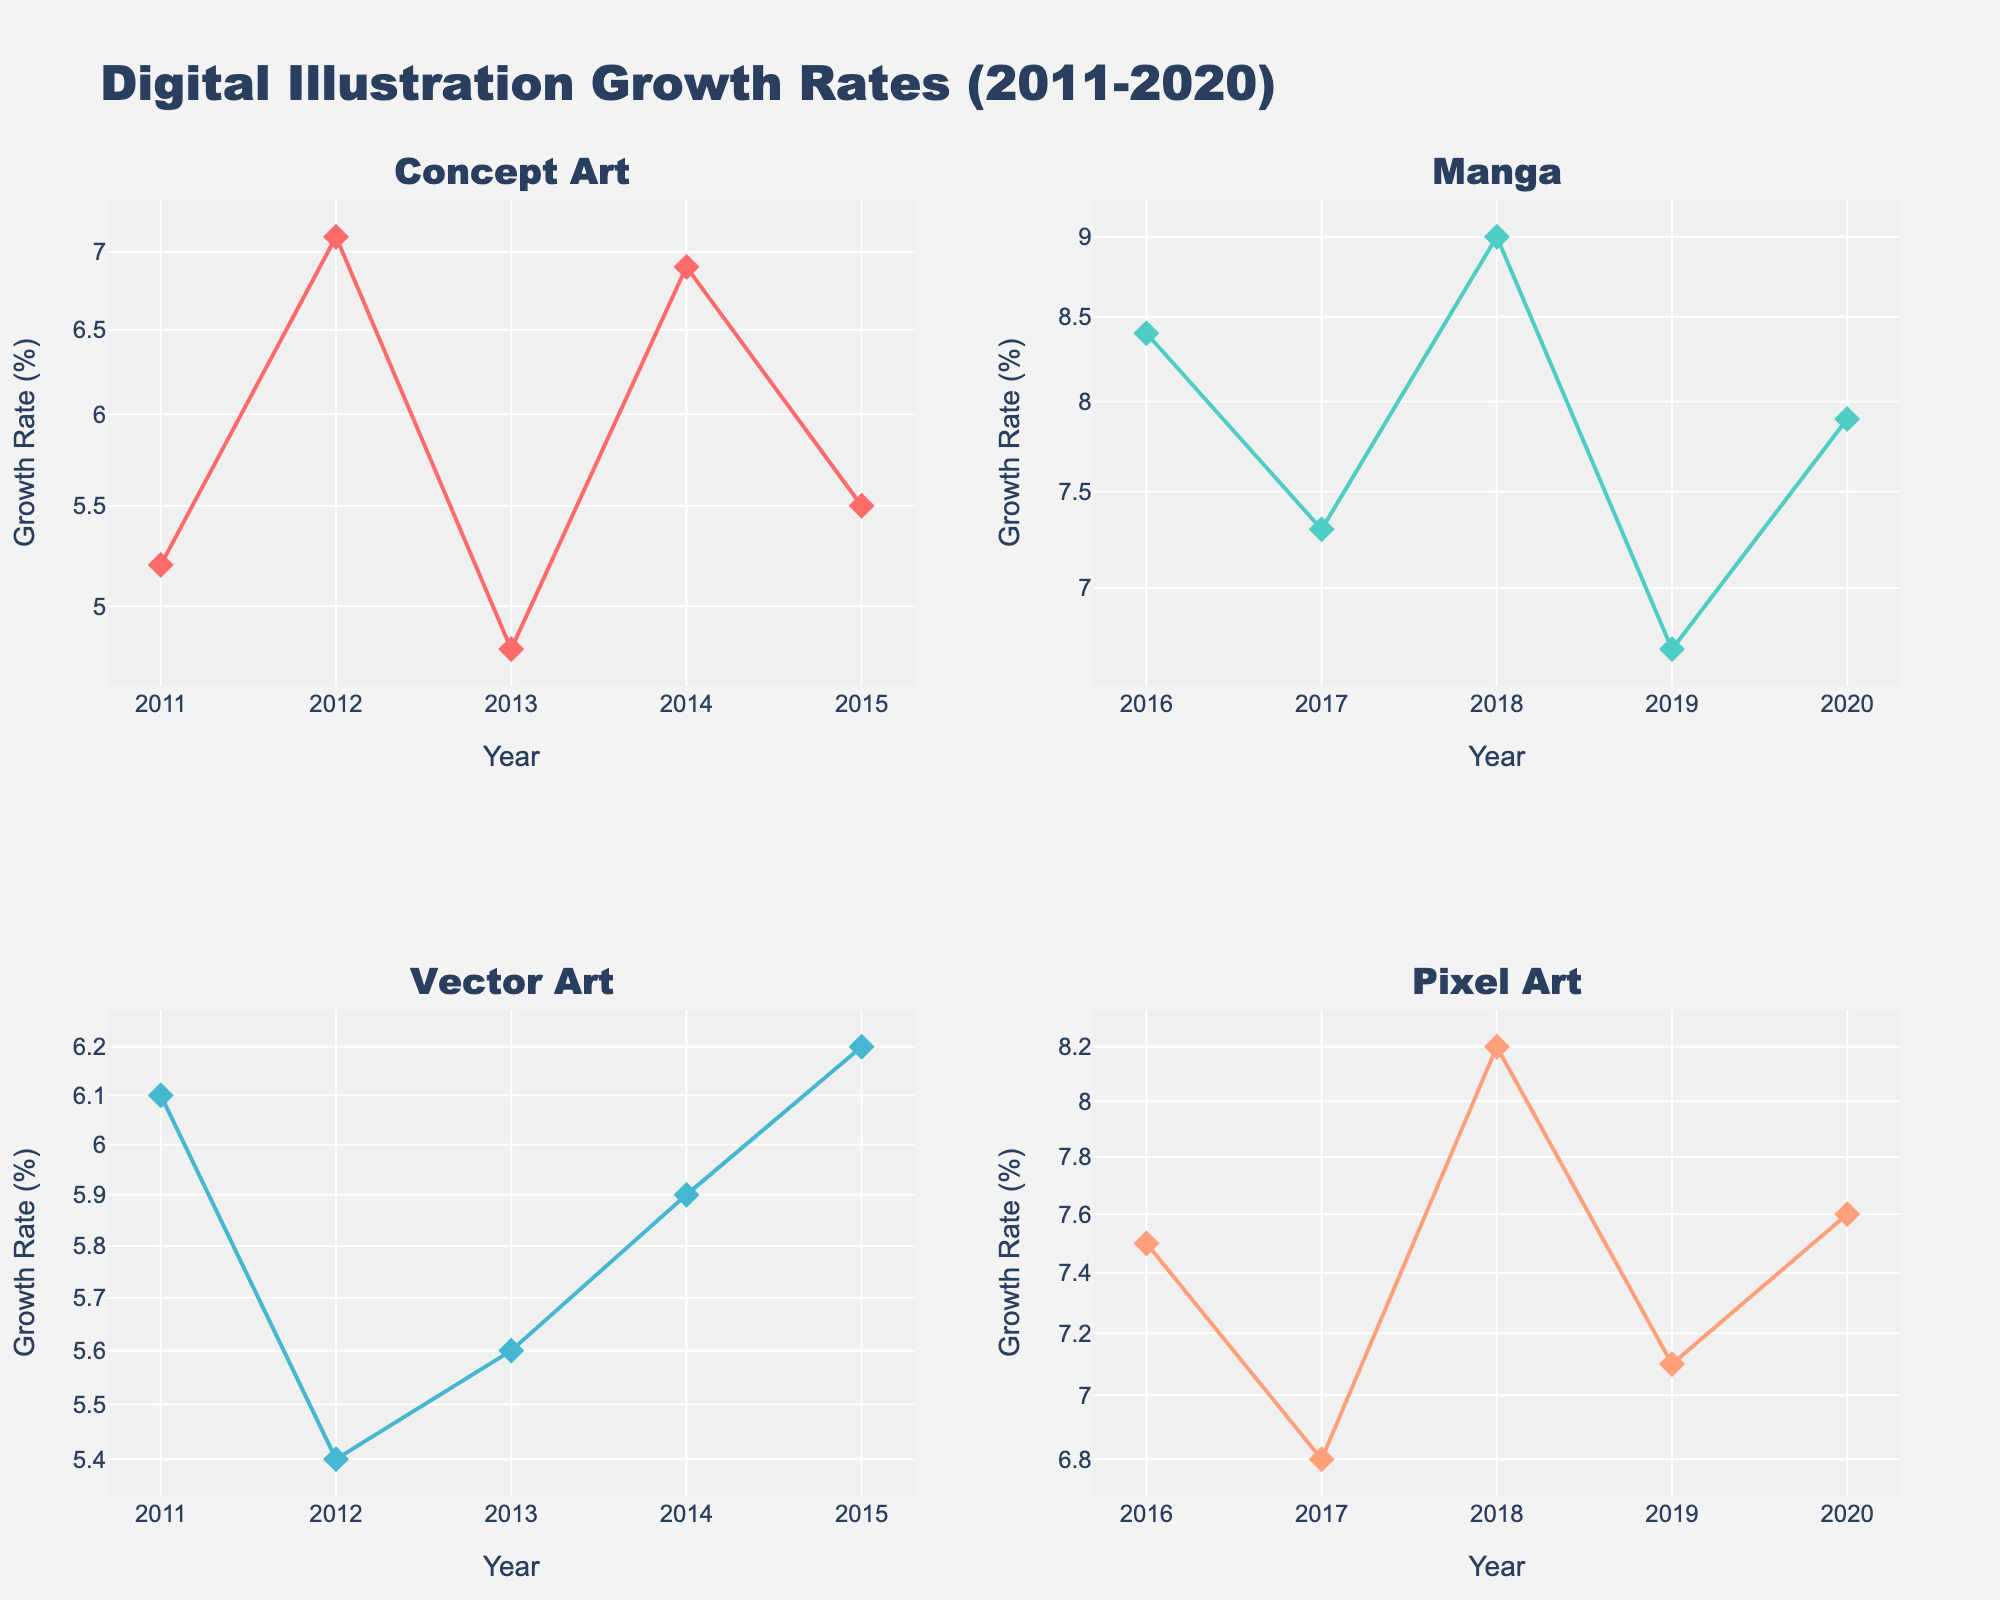What's the title of the figure? The title is usually displayed prominently at the top of the figure. In this case, the figure's title is "Digital Illustration Growth Rates (2011-2020)". This can be read directly from the figure.
Answer: Digital Illustration Growth Rates (2011-2020) What is the color used for the Concept Art data points? The color used for Concept Art data points can be identified by looking at the markers and lines in the subplot for Concept Art. They are colored with a bright red/pink hue.
Answer: Bright red/pink Which style had the highest annual growth rate and what was the value? The highest growth rates can be identified by looking at the highest points in each subplot. From the subplots, Manga in 2018 using MediBang Paint had the highest annual growth rate with a value of 9.0%.
Answer: Manga in 2018 and 9.0% Between 2011 and 2020, which year showed the highest growth rate in Pixel Art? Reviewing the Pixel Art subplot, the highest point represents the year with the highest growth rate. In this case, it is 2018 with a rate of 8.2%.
Answer: 2018 What tool was used for Concept Art in 2014 and what was its growth rate? In the Concept Art subplot, hover over the data point for 2014 shows that the tool used was Procreate with a growth rate of 6.9%.
Answer: Procreate and 6.9% Which year had the lowest growth rate for Vector Art? By observing the Vector Art subplot, the lowest point is around 2012, which shows a growth rate of 5.4%.
Answer: 2012 How many styles had a growth rate of above 7.0% in 2020? Examining each of the subplots for the year 2020 and counting the points above 7.0%. Manga with Infinite Painter and Pixel Art with Pyxel Edit both had growth rates above 7.0%. Thus, two styles had growth rates above 7.0% in 2020.
Answer: Two Compare the growth rate trends of Concept Art and Manga. Which one showed a more consistent growth rate? By looking at the subplots for both Concept Art and Manga, Concept Art shows more fluctuations in growth rates than Manga. Manga's rates progressively increase with less fluctuation, indicating more consistency.
Answer: Manga What pattern can you notice regarding the tools used for Manga over the years? Examining the Manga subplot, different tools are used almost every year. Clip Studio Paint in 2016, Comic Draw in 2017, MediBang Paint in 2018, Paint Tool SAI in 2019, and Infinite Painter in 2020, showing a switch in tools almost every year.
Answer: Different tools used each year What's the average growth rate for Pixel Art from 2016 to 2020? Locate and list the growth rates for Pixel Art from 2016 to 2020: 7.5, 6.8, 8.2, 7.1, and 7.6. Sum these values: 7.5 + 6.8 + 8.2 + 7.1 + 7.6 = 37.2. Then, divide by the number of years, which is 5. 37.2 / 5 = 7.44%.
Answer: 7.44% 